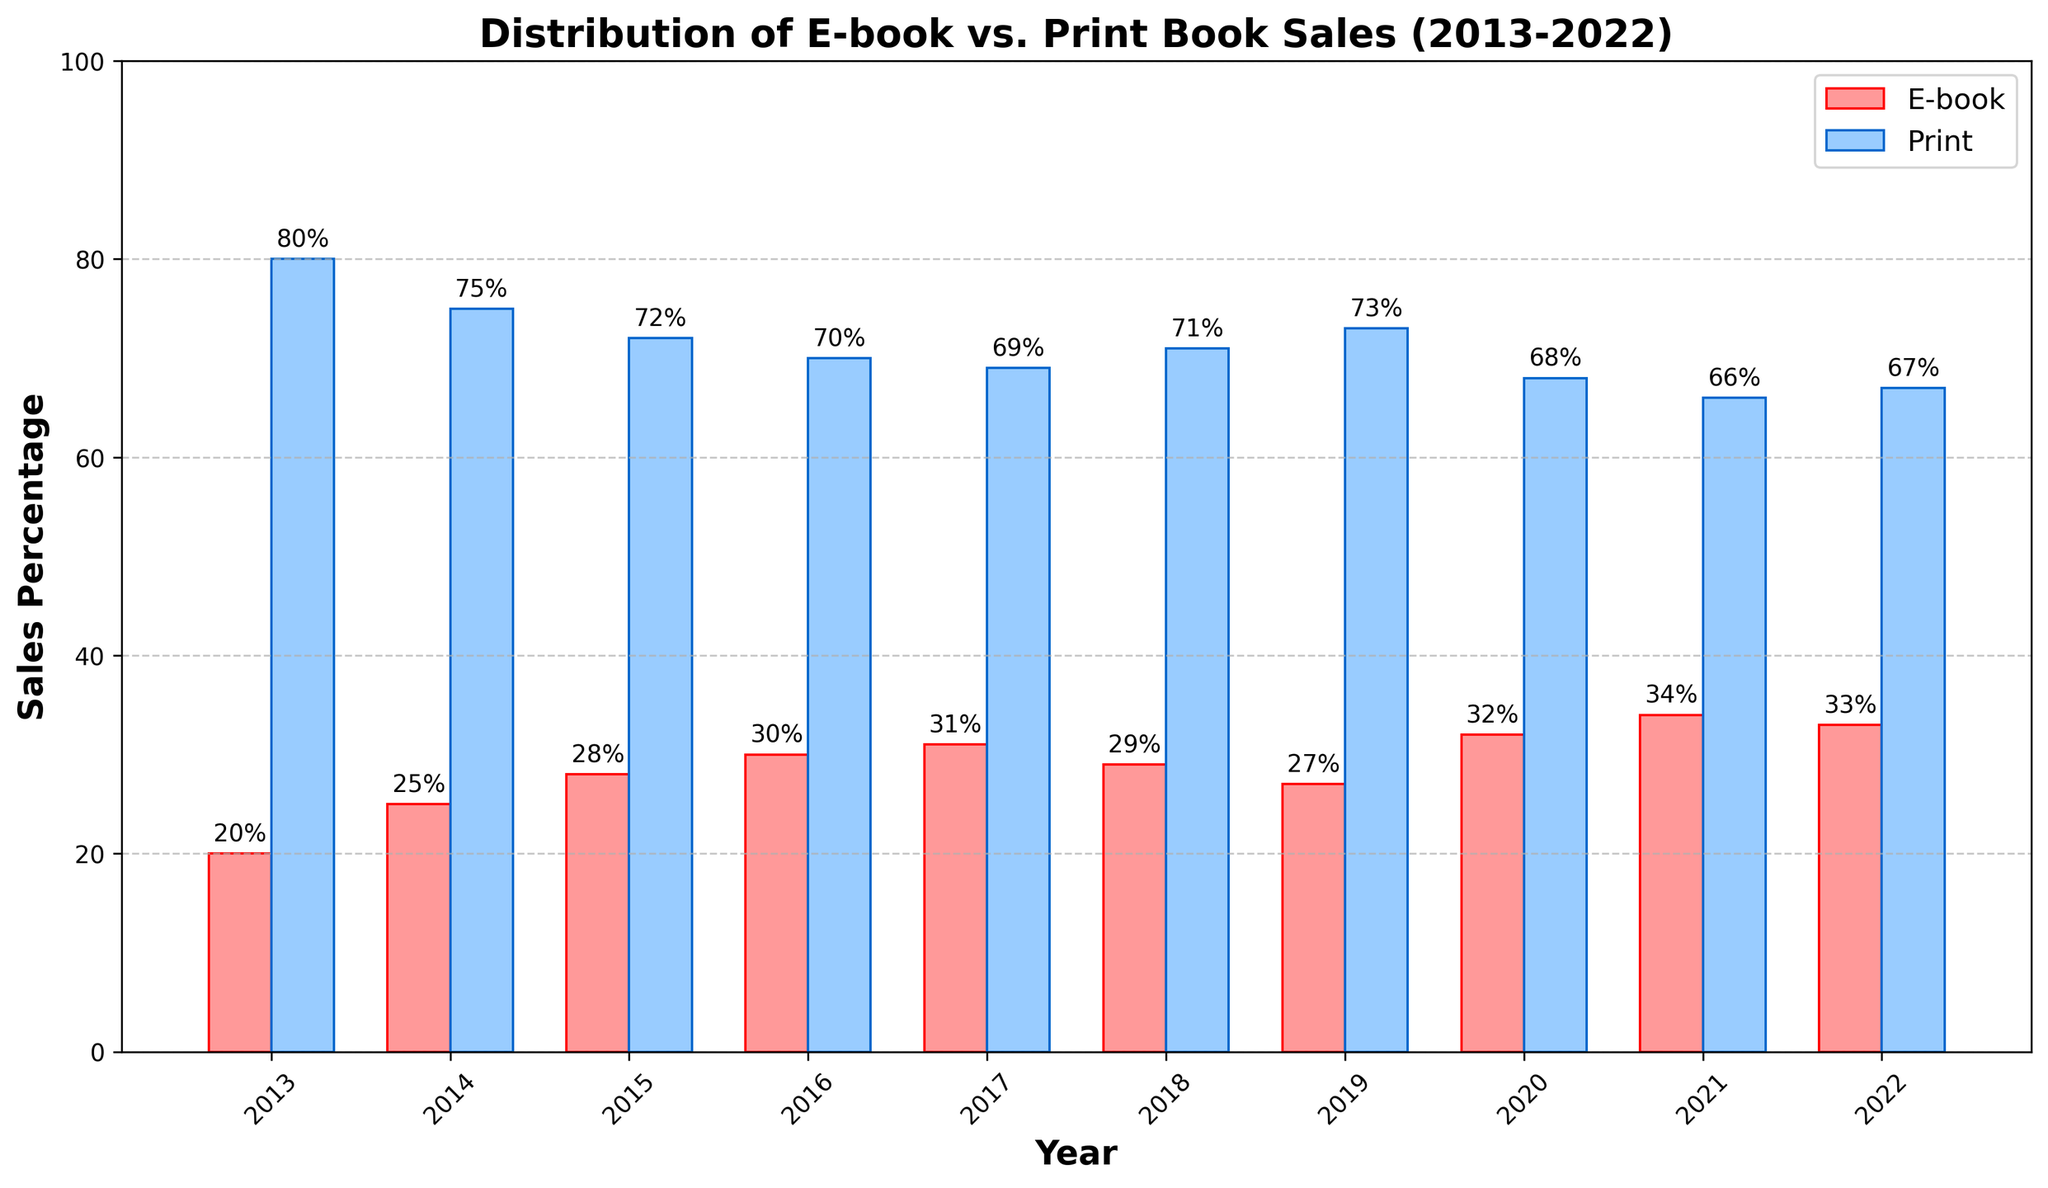Which year had the highest percentage of E-book sales? By examining the height of the red bars, we can identify the tallest one, which corresponds to the year 2021 at 34%.
Answer: 2021 In which year did Print book sales see a drop after increasing the previous year? From the data, we see that print book sales were 71% in 2018, which increased to 73% in 2019, and then dropped to 68% in 2020.
Answer: 2020 What is the percent change in E-book sales from 2013 to 2022? Subtract the value in 2013 (20%) from the value in 2022 (33%) and then divide by the 2013 value, finally multiply by 100: ((33 - 20) / 20) * 100.
Answer: 65% Between which consecutive years did E-book sales increase the most? Comparing the year-over-year increases: 
2013-2014: 5%, 2014-2015: 3%, 2015-2016: 2%, 2016-2017: 1%, 2017-2018: -2%, 2018-2019: -2%, 2019-2020: 5%, 2020-2021: 2%, 2021-2022: -1%. The largest increase is from 2013 to 2014.
Answer: 2013-2014 What was the average percentage of print book sales over the decade? Sum the percentage values from 2013 to 2022 for print book sales and divide by the number of years (10): (80 + 75 + 72 + 70 + 69 + 71 + 73 + 68 + 66 + 67) / 10 = 71.1.
Answer: 71.1% How many years saw E-book sales percentages higher than the initial value in 2013? We compare each year with the 2013 value (20%): All years from 2014 to 2022 have sales values greater than 20%.
Answer: 9 years Which color represents Print book sales in the chart? By looking at the legend, we see that Print book sales are represented by the blue bars.
Answer: Blue How many years did E-book sales percentages decrease compared to the previous year? Checking each year, decreases occurred in 2018 (from 31 to 29), 2019 (from 29 to 27), and 2022 (from 34 to 33).
Answer: 3 years In which year was the gap between E-book and Print book sales the smallest? By calculating the difference for each year, 2021 had the smallest gap of 32% (66% - 34%).
Answer: 2021 What is the total percentage of book sales (both E-book and Print) for the year 2020? Summing the percentages for 2020: E-book = 32%, Print book = 68%, total = 32% + 68% = 100%.
Answer: 100% 